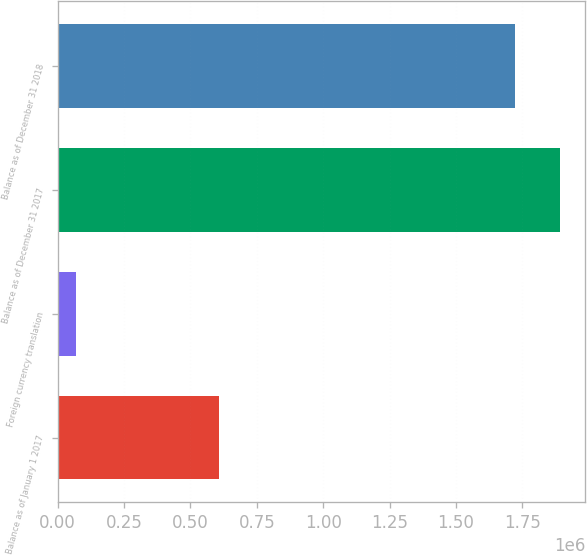Convert chart. <chart><loc_0><loc_0><loc_500><loc_500><bar_chart><fcel>Balance as of January 1 2017<fcel>Foreign currency translation<fcel>Balance as of December 31 2017<fcel>Balance as of December 31 2018<nl><fcel>607558<fcel>68183<fcel>1.89156e+06<fcel>1.72182e+06<nl></chart> 